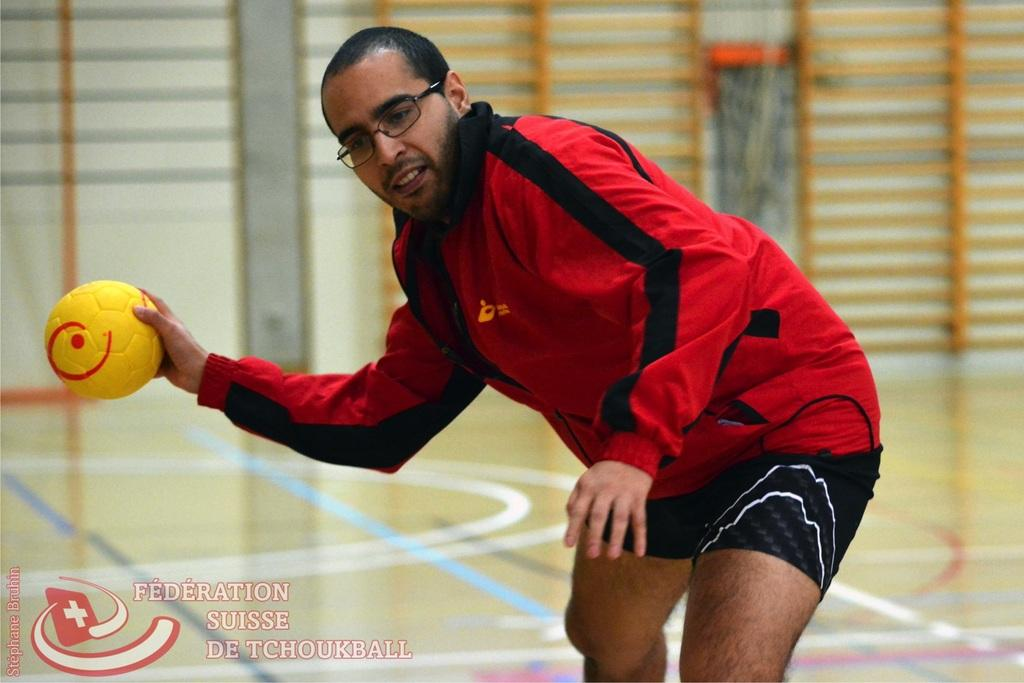What is the main subject of the image? There is a man in the image. What is the man doing in the image? The man is standing in the image. What object is the man holding in his hand? The man is holding a ball in his hand. What type of worm can be seen crawling on the man's arm in the image? There is no worm present on the man's arm in the image. What badge is the man wearing on his shirt in the image? The man is not wearing a badge on his shirt in the image. 